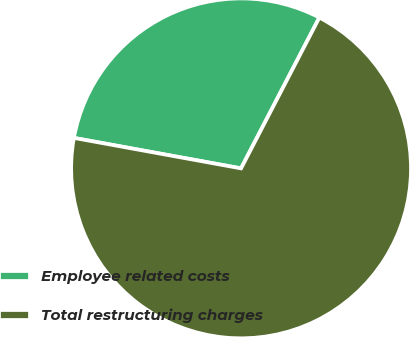Convert chart. <chart><loc_0><loc_0><loc_500><loc_500><pie_chart><fcel>Employee related costs<fcel>Total restructuring charges<nl><fcel>29.75%<fcel>70.25%<nl></chart> 